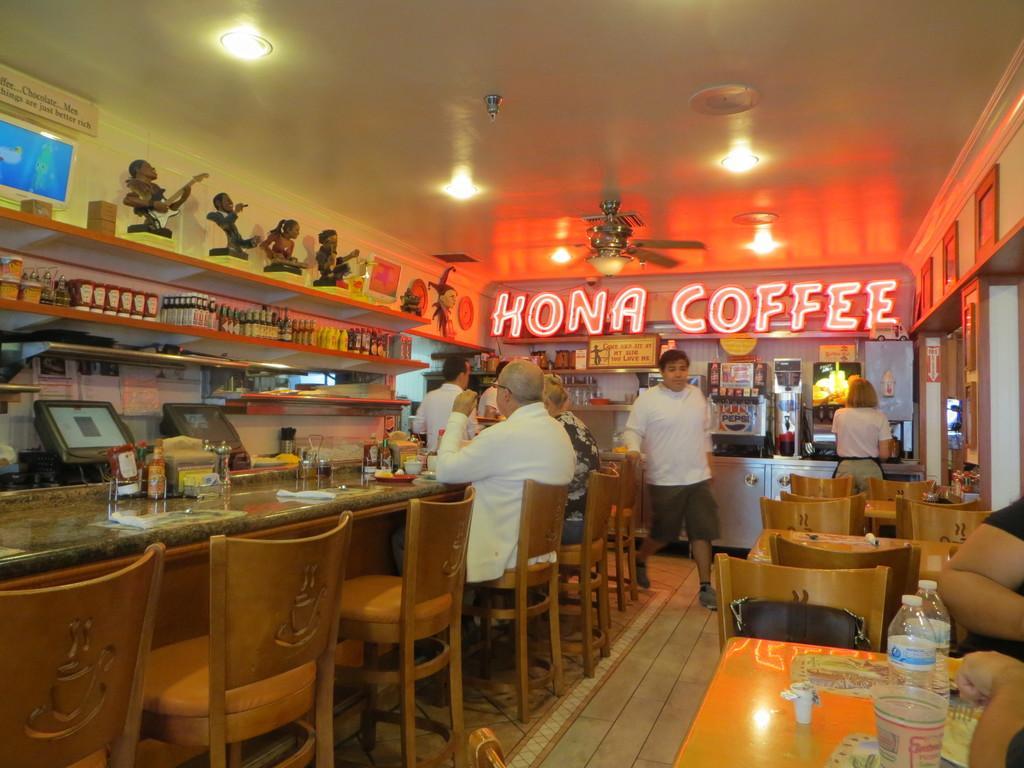Could you give a brief overview of what you see in this image? We can see honu coffee means this can be a coffee shop and here there are chairs placed and people are sitting here and standing, there is a bottle placed on the table, there are various lights 